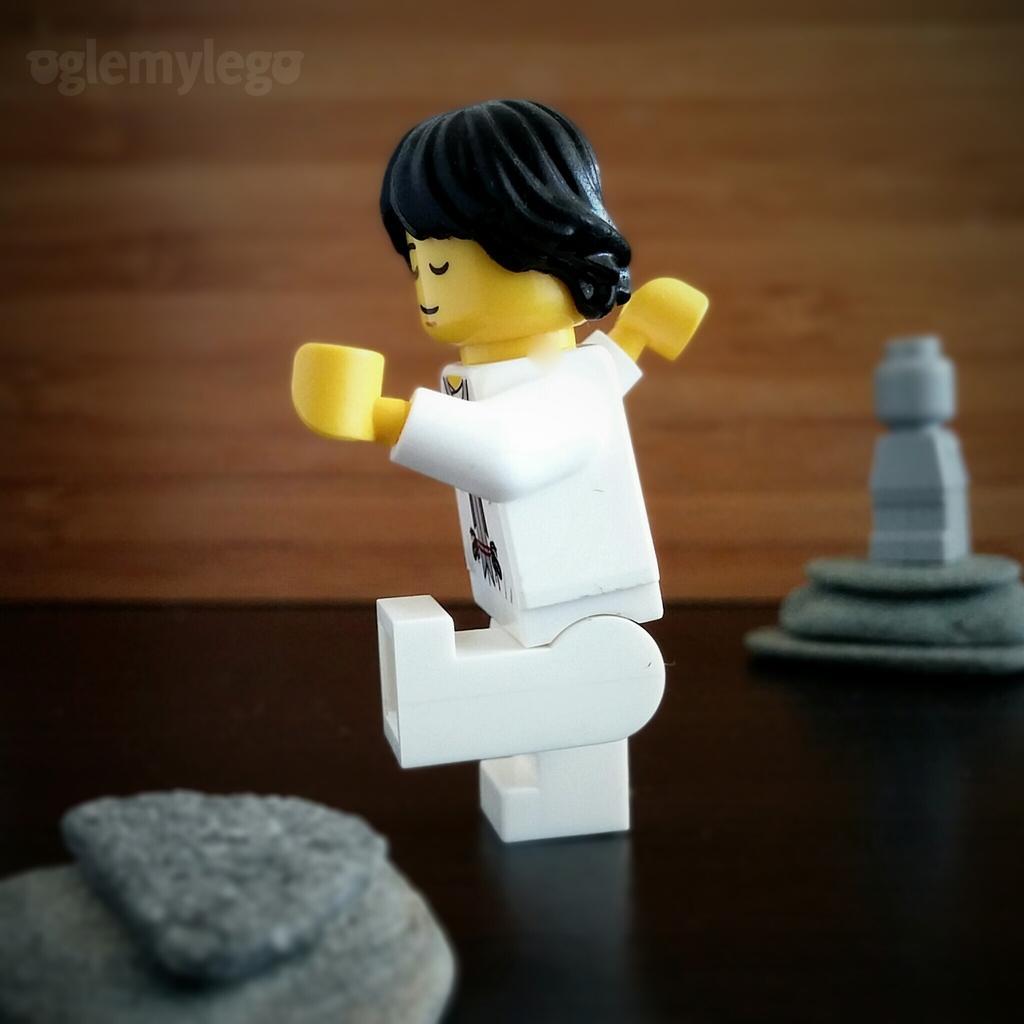Please provide a concise description of this image. In the image we can see there is a human toy kept on the table and there are other toys. 